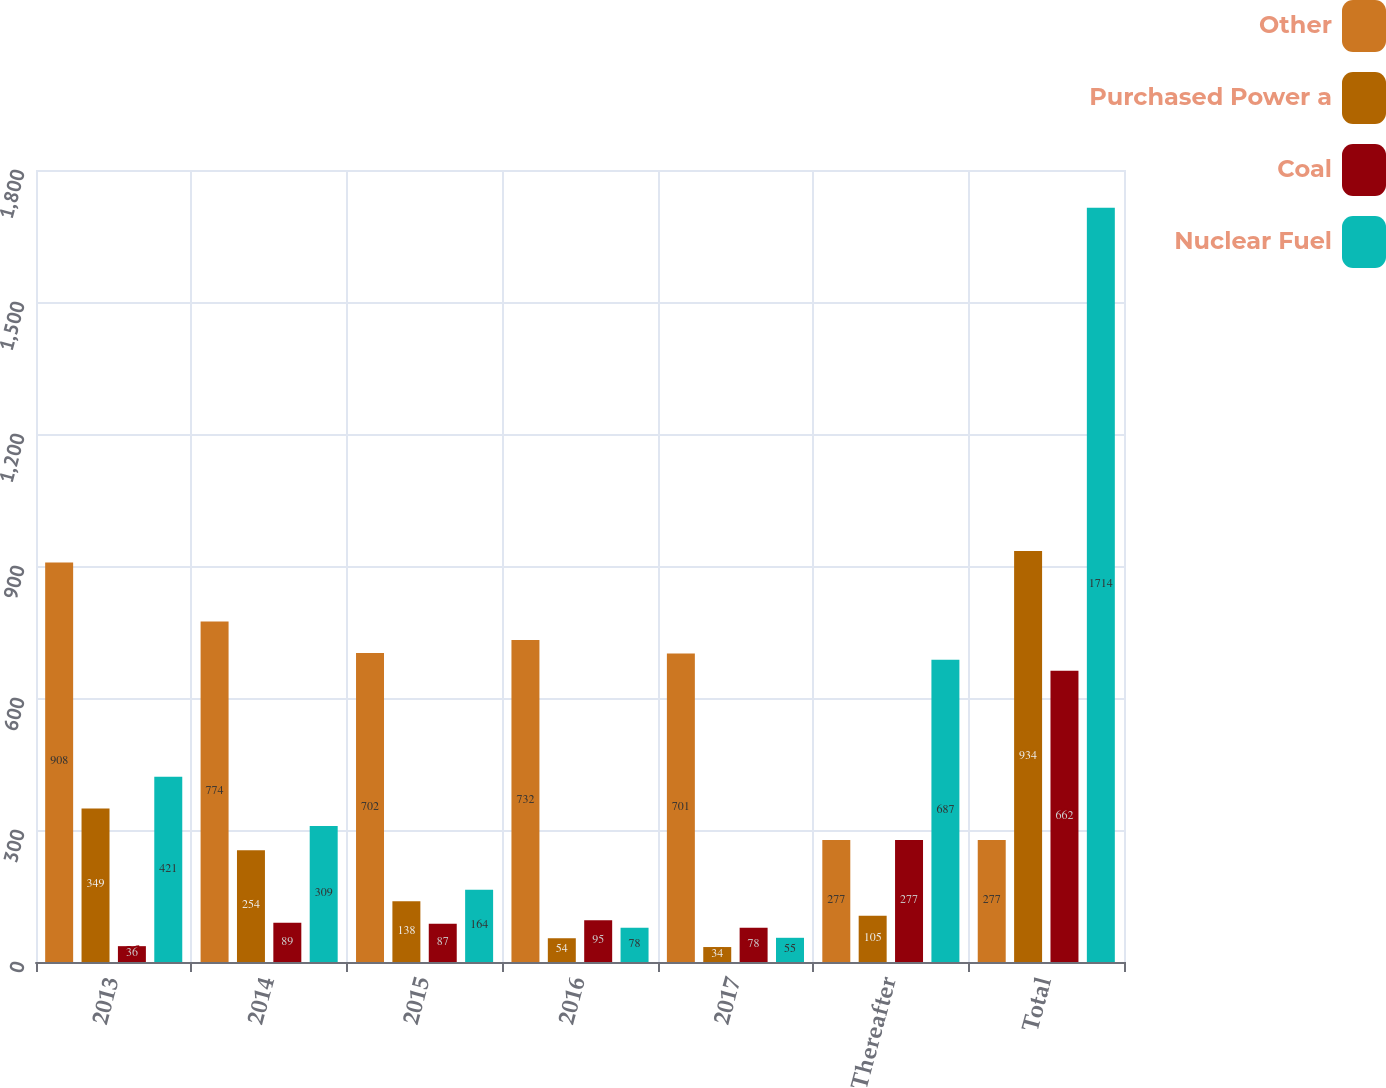<chart> <loc_0><loc_0><loc_500><loc_500><stacked_bar_chart><ecel><fcel>2013<fcel>2014<fcel>2015<fcel>2016<fcel>2017<fcel>Thereafter<fcel>Total<nl><fcel>Other<fcel>908<fcel>774<fcel>702<fcel>732<fcel>701<fcel>277<fcel>277<nl><fcel>Purchased Power a<fcel>349<fcel>254<fcel>138<fcel>54<fcel>34<fcel>105<fcel>934<nl><fcel>Coal<fcel>36<fcel>89<fcel>87<fcel>95<fcel>78<fcel>277<fcel>662<nl><fcel>Nuclear Fuel<fcel>421<fcel>309<fcel>164<fcel>78<fcel>55<fcel>687<fcel>1714<nl></chart> 